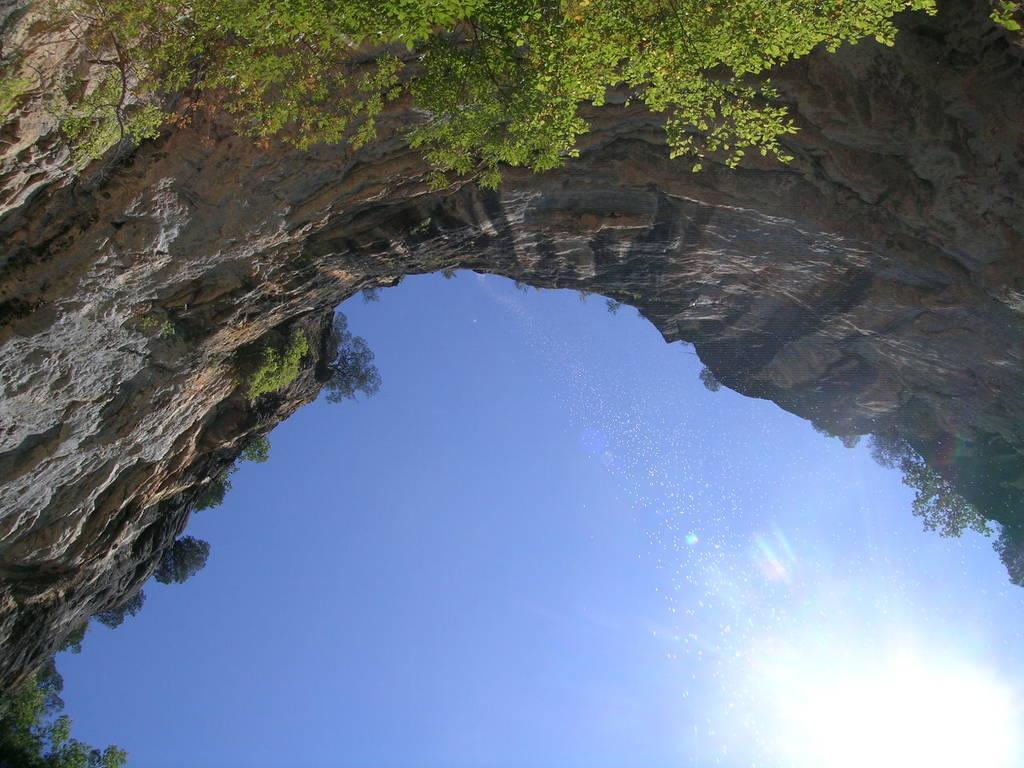Could you give a brief overview of what you see in this image? This picture might be taken outside of the city. In this image, on the right side corner, we can see a sun and few plants. On the left side corner, we can also see some trees and plants. In the middle of the image, we can see some trees and rocks. In the background, we can see a sky. 